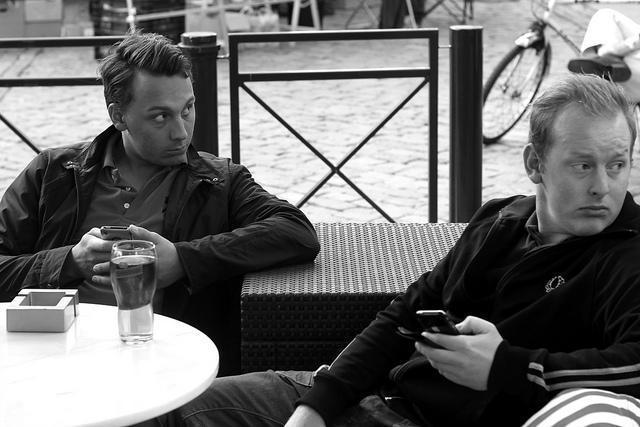How many men are there?
Give a very brief answer. 2. How many people are there?
Give a very brief answer. 3. How many umbrellas do you see?
Give a very brief answer. 0. 